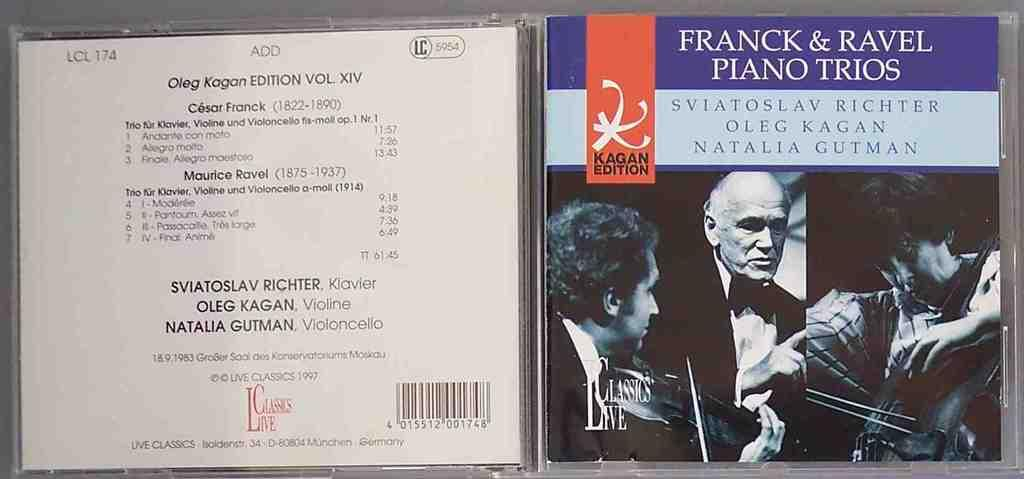<image>
Relay a brief, clear account of the picture shown. A CD case for Franck and Ravel's piano trios sits open and on display. 